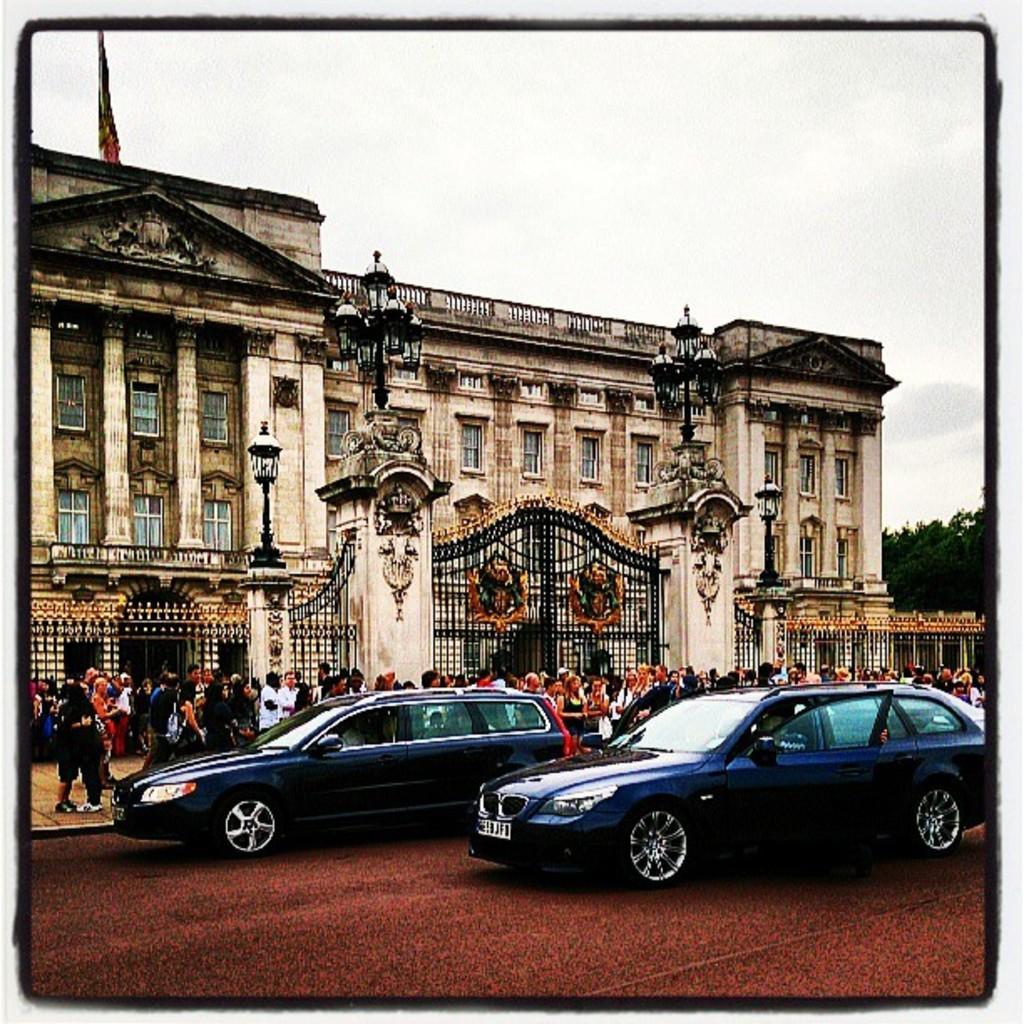How would you summarize this image in a sentence or two? At the bottom there are two cars on the road. In the middle few people are walking on the footpath. It is a monument, at the top it is the cloudy sky. 